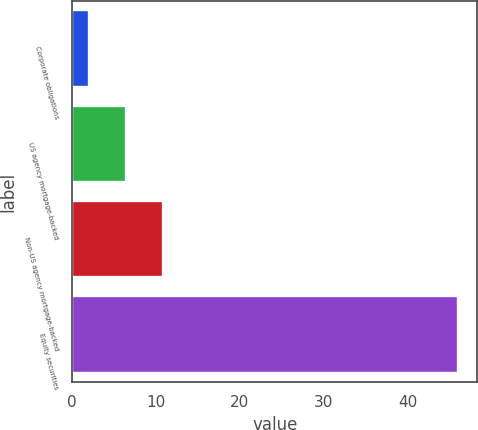Convert chart to OTSL. <chart><loc_0><loc_0><loc_500><loc_500><bar_chart><fcel>Corporate obligations<fcel>US agency mortgage-backed<fcel>Non-US agency mortgage-backed<fcel>Equity securities<nl><fcel>2<fcel>6.4<fcel>10.8<fcel>46<nl></chart> 